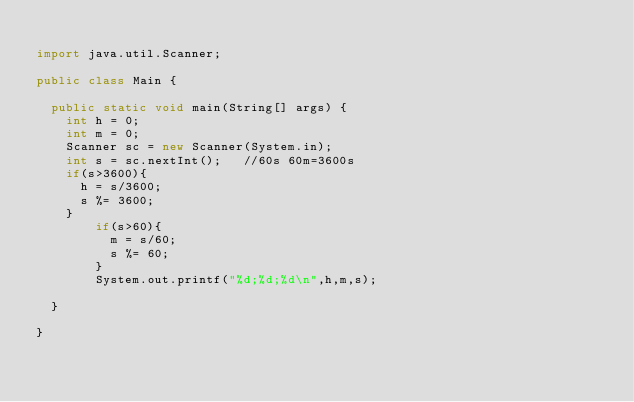<code> <loc_0><loc_0><loc_500><loc_500><_Java_>
import java.util.Scanner;

public class Main {

	public static void main(String[] args) {
		int h = 0;
		int m = 0;
		Scanner sc = new Scanner(System.in);
		int s = sc.nextInt();   //60s 60m=3600s
		if(s>3600){
			h = s/3600;
			s %= 3600;
		}
        if(s>60){
        	m = s/60;
        	s %= 60;
        }
        System.out.printf("%d;%d;%d\n",h,m,s);

	}

}</code> 